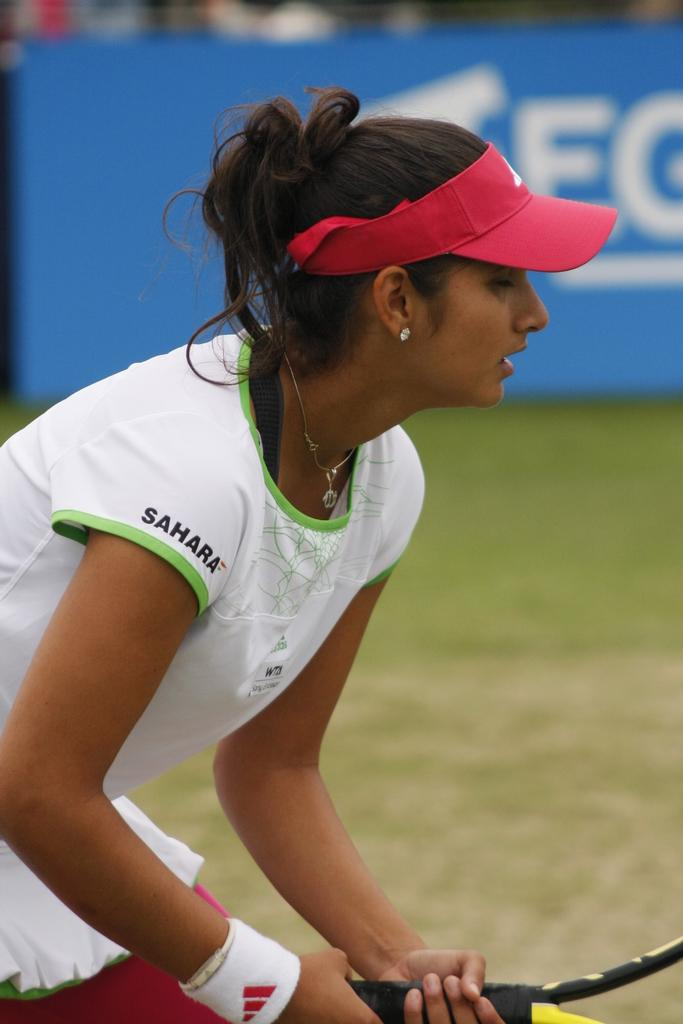Who is present in the image? There is a woman in the image. What is the woman doing in the image? The woman is standing and holding a tennis bat. What type of surface is visible in the image? There is grass visible in the image. What can be seen in the background of the image? There is a hoarding in the background of the image. What type of headwear is the woman wearing? The woman is wearing a cap. How many cows are present in the image? There are no cows present in the image. What type of cover is the woman using to protect herself from the sun? The woman is not using any cover to protect herself from the sun; she is wearing a cap. 